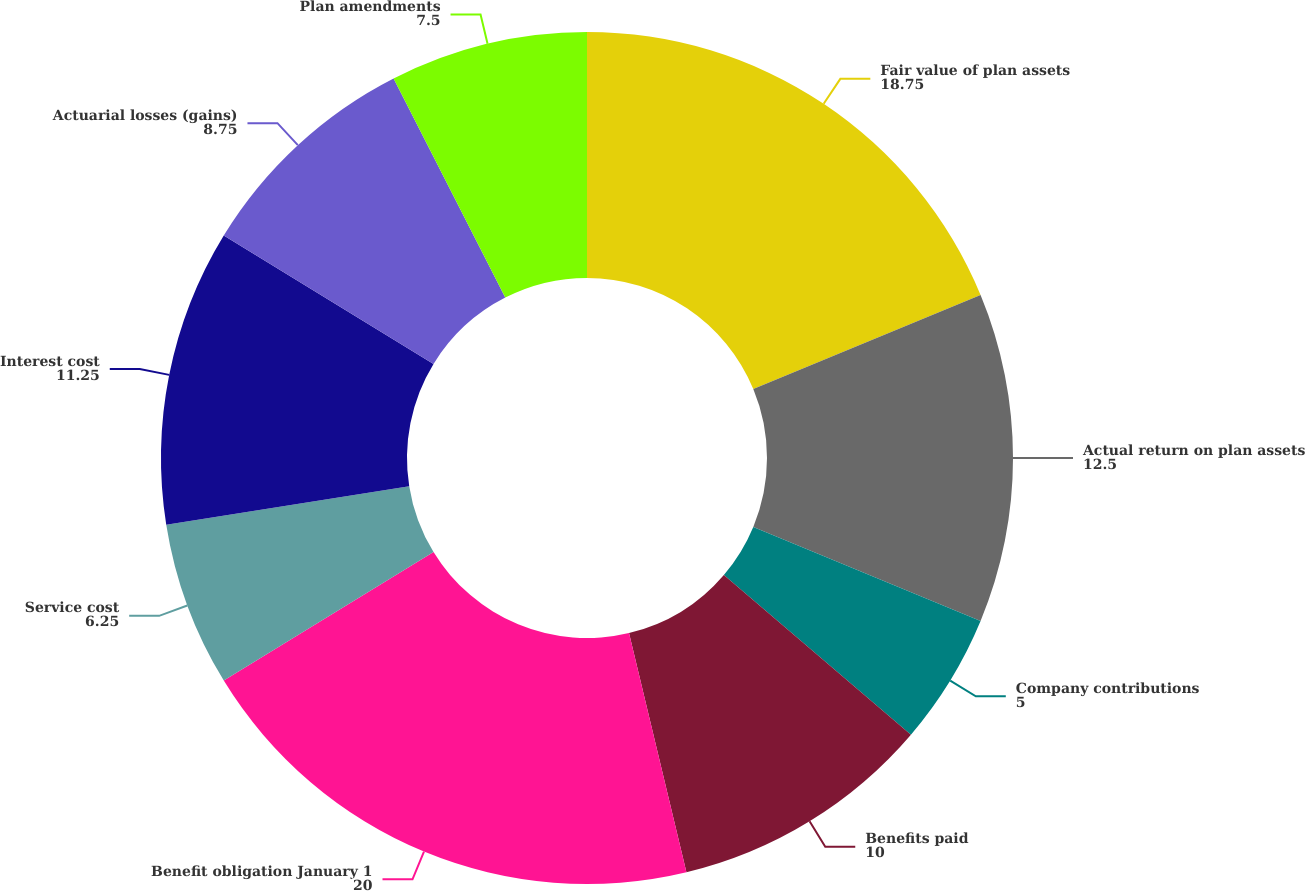Convert chart to OTSL. <chart><loc_0><loc_0><loc_500><loc_500><pie_chart><fcel>Fair value of plan assets<fcel>Actual return on plan assets<fcel>Company contributions<fcel>Benefits paid<fcel>Benefit obligation January 1<fcel>Service cost<fcel>Interest cost<fcel>Actuarial losses (gains)<fcel>Plan amendments<nl><fcel>18.75%<fcel>12.5%<fcel>5.0%<fcel>10.0%<fcel>20.0%<fcel>6.25%<fcel>11.25%<fcel>8.75%<fcel>7.5%<nl></chart> 